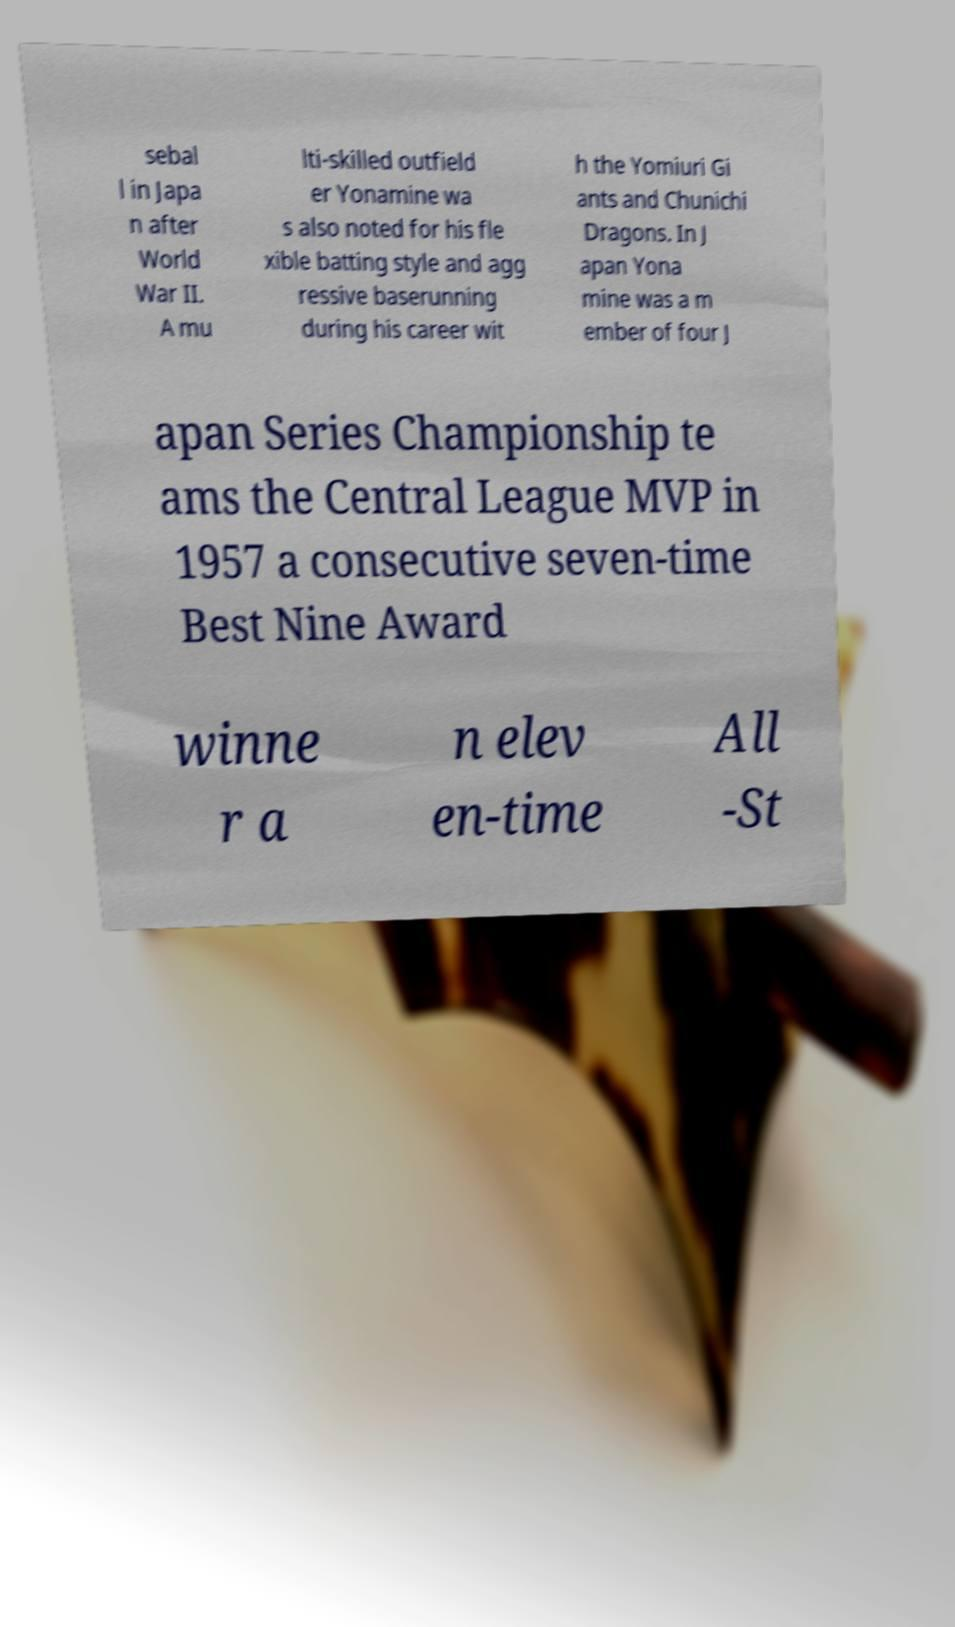Could you extract and type out the text from this image? sebal l in Japa n after World War II. A mu lti-skilled outfield er Yonamine wa s also noted for his fle xible batting style and agg ressive baserunning during his career wit h the Yomiuri Gi ants and Chunichi Dragons. In J apan Yona mine was a m ember of four J apan Series Championship te ams the Central League MVP in 1957 a consecutive seven-time Best Nine Award winne r a n elev en-time All -St 